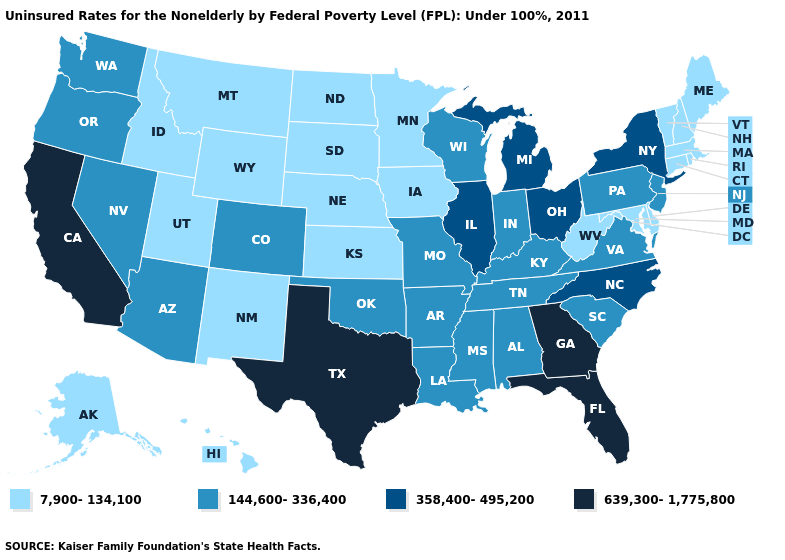Is the legend a continuous bar?
Quick response, please. No. Name the states that have a value in the range 7,900-134,100?
Keep it brief. Alaska, Connecticut, Delaware, Hawaii, Idaho, Iowa, Kansas, Maine, Maryland, Massachusetts, Minnesota, Montana, Nebraska, New Hampshire, New Mexico, North Dakota, Rhode Island, South Dakota, Utah, Vermont, West Virginia, Wyoming. Does Iowa have the same value as New Mexico?
Write a very short answer. Yes. What is the value of Hawaii?
Keep it brief. 7,900-134,100. What is the value of Massachusetts?
Answer briefly. 7,900-134,100. Which states have the lowest value in the West?
Quick response, please. Alaska, Hawaii, Idaho, Montana, New Mexico, Utah, Wyoming. Among the states that border New Hampshire , which have the highest value?
Keep it brief. Maine, Massachusetts, Vermont. Name the states that have a value in the range 639,300-1,775,800?
Give a very brief answer. California, Florida, Georgia, Texas. Name the states that have a value in the range 144,600-336,400?
Give a very brief answer. Alabama, Arizona, Arkansas, Colorado, Indiana, Kentucky, Louisiana, Mississippi, Missouri, Nevada, New Jersey, Oklahoma, Oregon, Pennsylvania, South Carolina, Tennessee, Virginia, Washington, Wisconsin. Name the states that have a value in the range 358,400-495,200?
Keep it brief. Illinois, Michigan, New York, North Carolina, Ohio. Name the states that have a value in the range 358,400-495,200?
Answer briefly. Illinois, Michigan, New York, North Carolina, Ohio. Name the states that have a value in the range 144,600-336,400?
Write a very short answer. Alabama, Arizona, Arkansas, Colorado, Indiana, Kentucky, Louisiana, Mississippi, Missouri, Nevada, New Jersey, Oklahoma, Oregon, Pennsylvania, South Carolina, Tennessee, Virginia, Washington, Wisconsin. What is the value of New Mexico?
Answer briefly. 7,900-134,100. What is the value of Nebraska?
Short answer required. 7,900-134,100. What is the highest value in states that border Colorado?
Keep it brief. 144,600-336,400. 